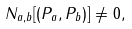<formula> <loc_0><loc_0><loc_500><loc_500>N _ { a , b } [ ( { P } _ { a } , { P } _ { b } ) ] \neq 0 ,</formula> 